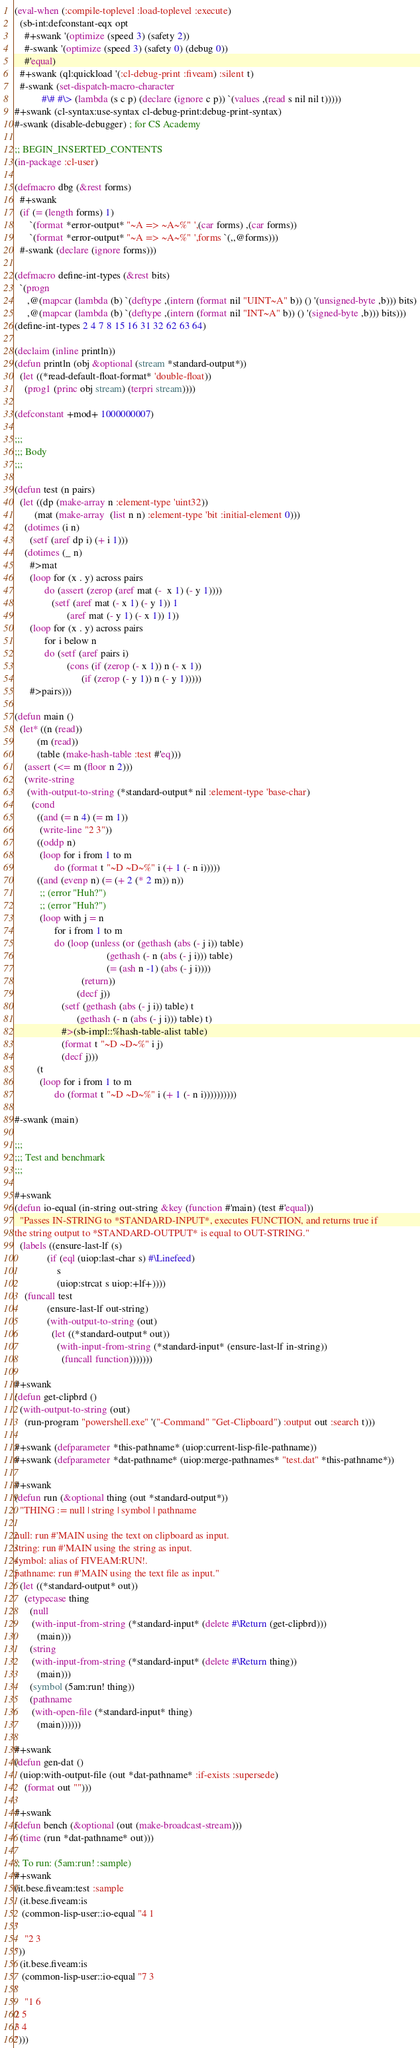Convert code to text. <code><loc_0><loc_0><loc_500><loc_500><_Lisp_>(eval-when (:compile-toplevel :load-toplevel :execute)
  (sb-int:defconstant-eqx opt
    #+swank '(optimize (speed 3) (safety 2))
    #-swank '(optimize (speed 3) (safety 0) (debug 0))
    #'equal)
  #+swank (ql:quickload '(:cl-debug-print :fiveam) :silent t)
  #-swank (set-dispatch-macro-character
           #\# #\> (lambda (s c p) (declare (ignore c p)) `(values ,(read s nil nil t)))))
#+swank (cl-syntax:use-syntax cl-debug-print:debug-print-syntax)
#-swank (disable-debugger) ; for CS Academy

;; BEGIN_INSERTED_CONTENTS
(in-package :cl-user)

(defmacro dbg (&rest forms)
  #+swank
  (if (= (length forms) 1)
      `(format *error-output* "~A => ~A~%" ',(car forms) ,(car forms))
      `(format *error-output* "~A => ~A~%" ',forms `(,,@forms)))
  #-swank (declare (ignore forms)))

(defmacro define-int-types (&rest bits)
  `(progn
     ,@(mapcar (lambda (b) `(deftype ,(intern (format nil "UINT~A" b)) () '(unsigned-byte ,b))) bits)
     ,@(mapcar (lambda (b) `(deftype ,(intern (format nil "INT~A" b)) () '(signed-byte ,b))) bits)))
(define-int-types 2 4 7 8 15 16 31 32 62 63 64)

(declaim (inline println))
(defun println (obj &optional (stream *standard-output*))
  (let ((*read-default-float-format* 'double-float))
    (prog1 (princ obj stream) (terpri stream))))

(defconstant +mod+ 1000000007)

;;;
;;; Body
;;;

(defun test (n pairs)
  (let ((dp (make-array n :element-type 'uint32))
        (mat (make-array  (list n n) :element-type 'bit :initial-element 0)))
    (dotimes (i n)
      (setf (aref dp i) (+ i 1)))
    (dotimes (_ n)
      #>mat
      (loop for (x . y) across pairs
            do (assert (zerop (aref mat (-  x 1) (- y 1))))
               (setf (aref mat (- x 1) (- y 1)) 1
                     (aref mat (- y 1) (- x 1)) 1))
      (loop for (x . y) across pairs
            for i below n
            do (setf (aref pairs i)
                     (cons (if (zerop (- x 1)) n (- x 1))
                           (if (zerop (- y 1)) n (- y 1)))))
      #>pairs)))

(defun main ()
  (let* ((n (read))
         (m (read))
         (table (make-hash-table :test #'eq)))
    (assert (<= m (floor n 2)))
    (write-string
     (with-output-to-string (*standard-output* nil :element-type 'base-char)
       (cond
         ((and (= n 4) (= m 1))
          (write-line "2 3"))
         ((oddp n)
          (loop for i from 1 to m
                do (format t "~D ~D~%" i (+ 1 (- n i)))))
         ((and (evenp n) (= (+ 2 (* 2 m)) n))
          ;; (error "Huh?")
          ;; (error "Huh?")
          (loop with j = n
                for i from 1 to m
                do (loop (unless (or (gethash (abs (- j i)) table)
                                     (gethash (- n (abs (- j i))) table)
                                     (= (ash n -1) (abs (- j i))))
                           (return))
                         (decf j))
                   (setf (gethash (abs (- j i)) table) t
                         (gethash (- n (abs (- j i))) table) t)
                   #>(sb-impl::%hash-table-alist table)
                   (format t "~D ~D~%" i j)
                   (decf j)))
         (t
          (loop for i from 1 to m
                do (format t "~D ~D~%" i (+ 1 (- n i))))))))))

#-swank (main)

;;;
;;; Test and benchmark
;;;

#+swank
(defun io-equal (in-string out-string &key (function #'main) (test #'equal))
  "Passes IN-STRING to *STANDARD-INPUT*, executes FUNCTION, and returns true if
the string output to *STANDARD-OUTPUT* is equal to OUT-STRING."
  (labels ((ensure-last-lf (s)
             (if (eql (uiop:last-char s) #\Linefeed)
                 s
                 (uiop:strcat s uiop:+lf+))))
    (funcall test
             (ensure-last-lf out-string)
             (with-output-to-string (out)
               (let ((*standard-output* out))
                 (with-input-from-string (*standard-input* (ensure-last-lf in-string))
                   (funcall function)))))))

#+swank
(defun get-clipbrd ()
  (with-output-to-string (out)
    (run-program "powershell.exe" '("-Command" "Get-Clipboard") :output out :search t)))

#+swank (defparameter *this-pathname* (uiop:current-lisp-file-pathname))
#+swank (defparameter *dat-pathname* (uiop:merge-pathnames* "test.dat" *this-pathname*))

#+swank
(defun run (&optional thing (out *standard-output*))
  "THING := null | string | symbol | pathname

null: run #'MAIN using the text on clipboard as input.
string: run #'MAIN using the string as input.
symbol: alias of FIVEAM:RUN!.
pathname: run #'MAIN using the text file as input."
  (let ((*standard-output* out))
    (etypecase thing
      (null
       (with-input-from-string (*standard-input* (delete #\Return (get-clipbrd)))
         (main)))
      (string
       (with-input-from-string (*standard-input* (delete #\Return thing))
         (main)))
      (symbol (5am:run! thing))
      (pathname
       (with-open-file (*standard-input* thing)
         (main))))))

#+swank
(defun gen-dat ()
  (uiop:with-output-file (out *dat-pathname* :if-exists :supersede)
    (format out "")))

#+swank
(defun bench (&optional (out (make-broadcast-stream)))
  (time (run *dat-pathname* out)))

;; To run: (5am:run! :sample)
#+swank
(it.bese.fiveam:test :sample
  (it.bese.fiveam:is
   (common-lisp-user::io-equal "4 1
"
    "2 3
"))
  (it.bese.fiveam:is
   (common-lisp-user::io-equal "7 3
"
    "1 6
2 5
3 4
")))
</code> 